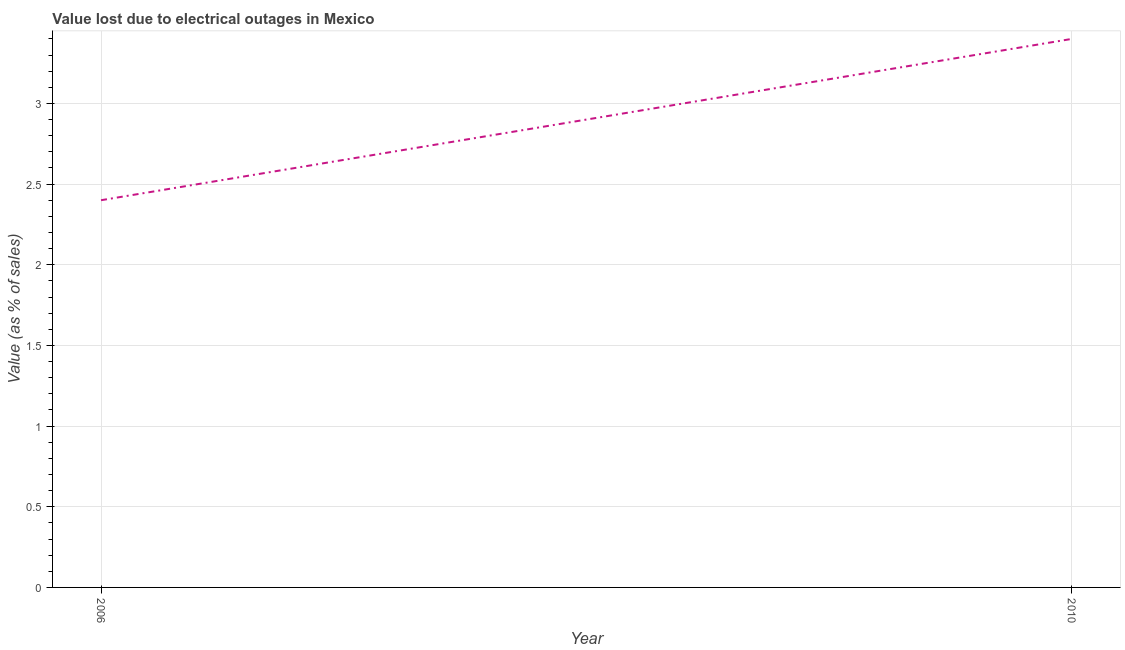What is the value lost due to electrical outages in 2010?
Provide a succinct answer. 3.4. Across all years, what is the minimum value lost due to electrical outages?
Offer a terse response. 2.4. In which year was the value lost due to electrical outages minimum?
Provide a short and direct response. 2006. What is the sum of the value lost due to electrical outages?
Make the answer very short. 5.8. What is the difference between the value lost due to electrical outages in 2006 and 2010?
Provide a short and direct response. -1. What is the average value lost due to electrical outages per year?
Offer a very short reply. 2.9. What is the median value lost due to electrical outages?
Give a very brief answer. 2.9. In how many years, is the value lost due to electrical outages greater than 2.9 %?
Provide a succinct answer. 1. What is the ratio of the value lost due to electrical outages in 2006 to that in 2010?
Ensure brevity in your answer.  0.71. In how many years, is the value lost due to electrical outages greater than the average value lost due to electrical outages taken over all years?
Give a very brief answer. 1. Does the value lost due to electrical outages monotonically increase over the years?
Ensure brevity in your answer.  Yes. How many lines are there?
Ensure brevity in your answer.  1. How many years are there in the graph?
Provide a short and direct response. 2. What is the title of the graph?
Make the answer very short. Value lost due to electrical outages in Mexico. What is the label or title of the X-axis?
Offer a very short reply. Year. What is the label or title of the Y-axis?
Make the answer very short. Value (as % of sales). What is the Value (as % of sales) in 2006?
Offer a terse response. 2.4. What is the ratio of the Value (as % of sales) in 2006 to that in 2010?
Your response must be concise. 0.71. 